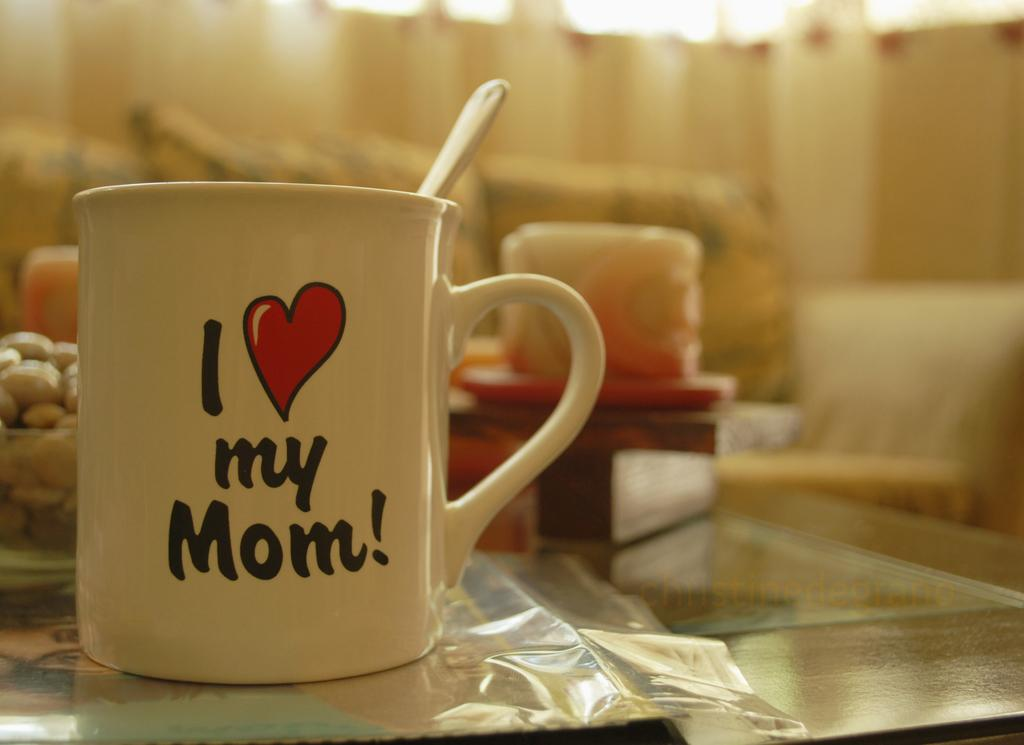<image>
Render a clear and concise summary of the photo. A coffee mug that says I love my Mom with a heart for the word love. 